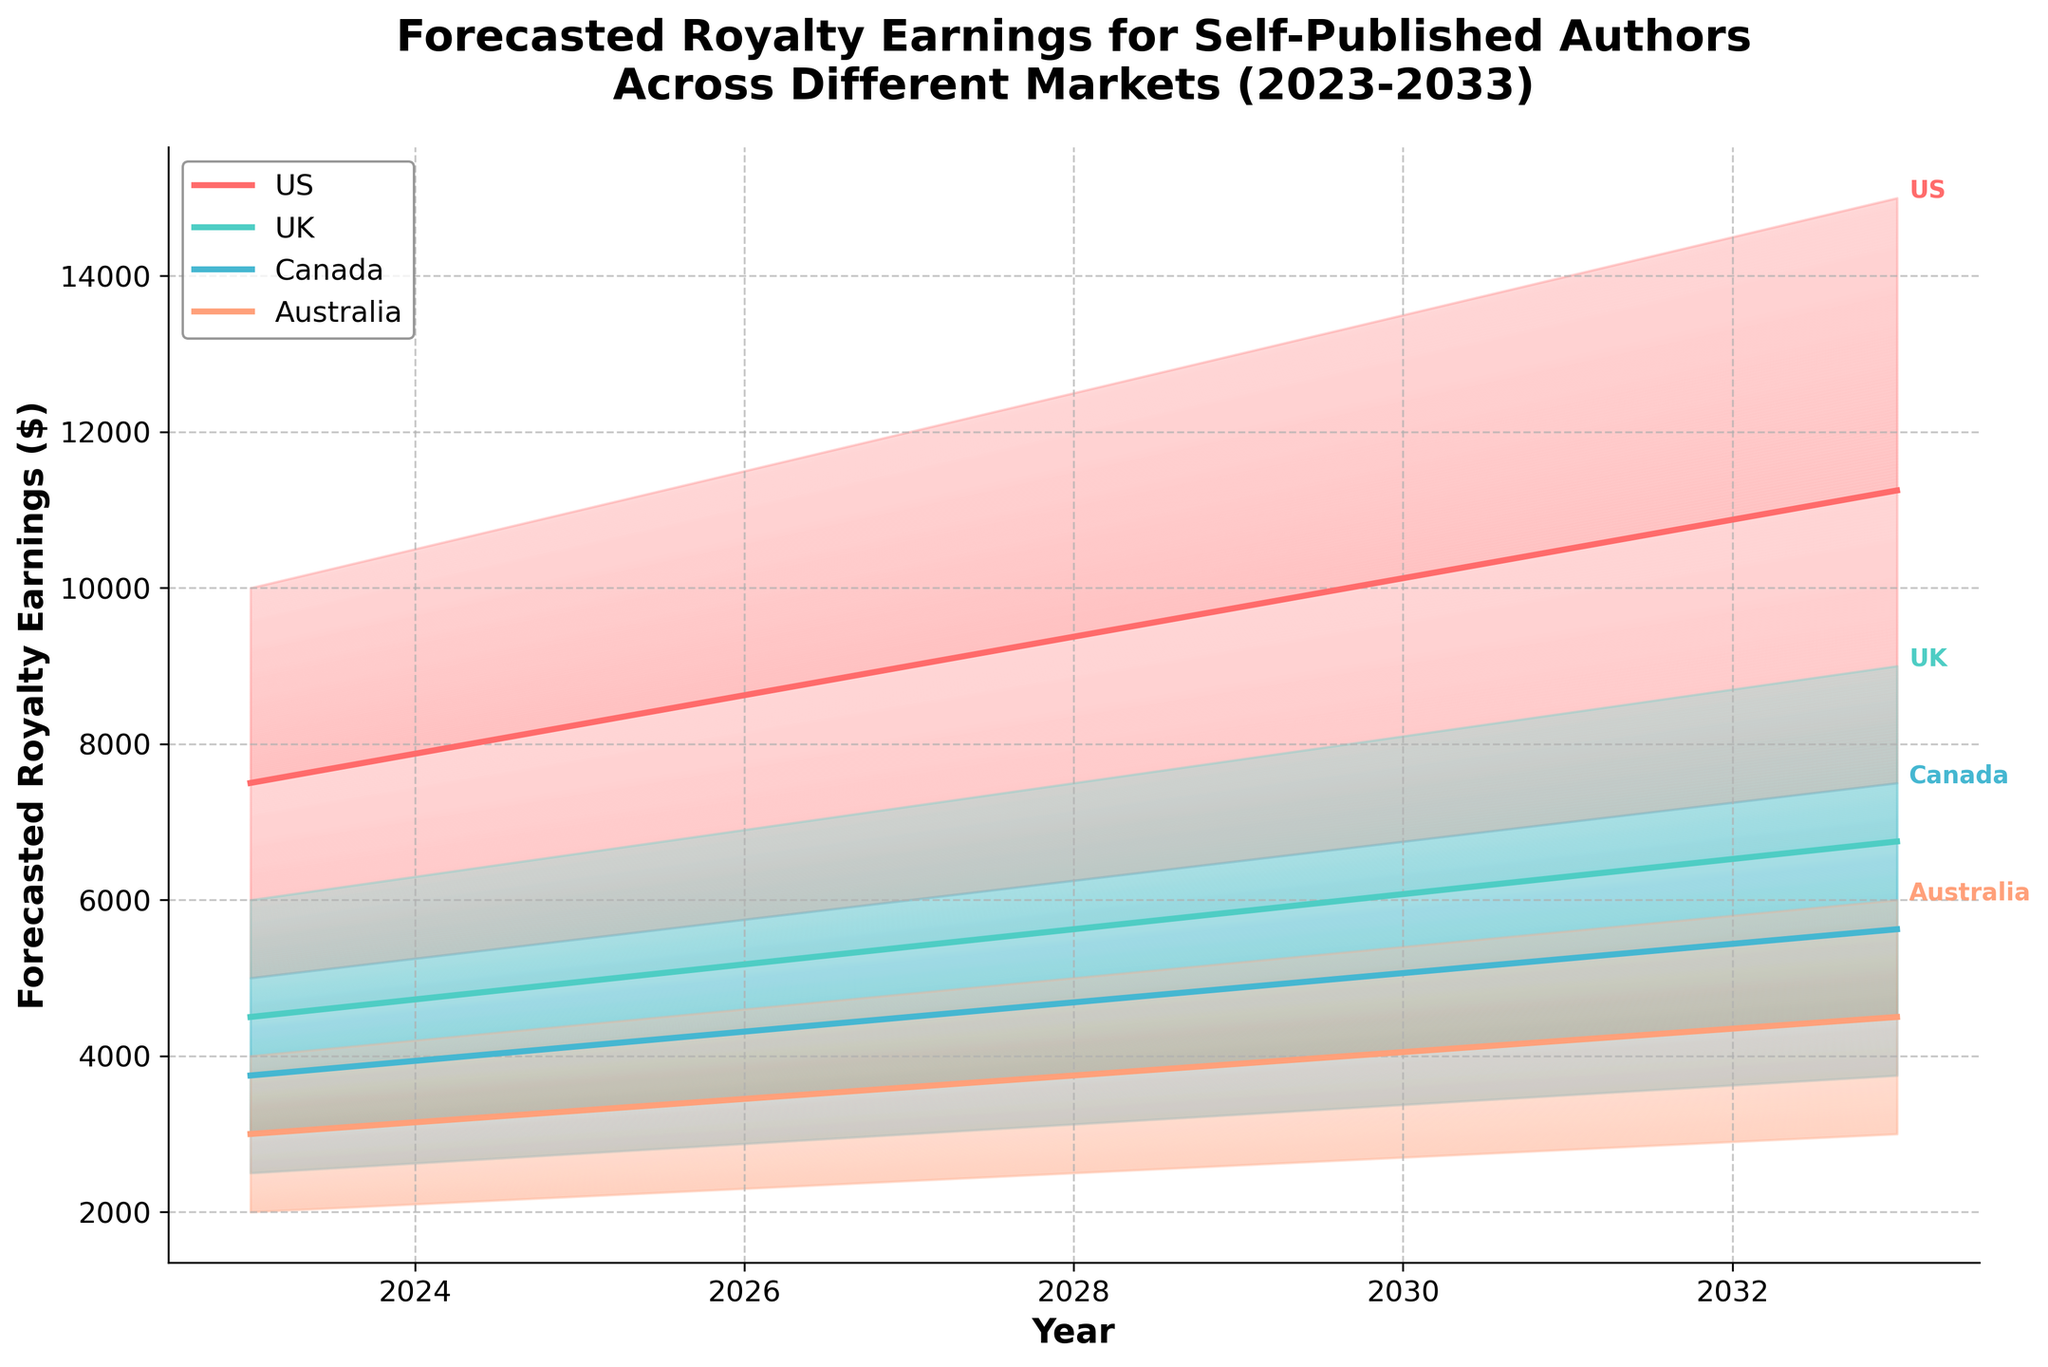What's the title of the figure? The title is prominently displayed at the top of the figure and summarizes what the figure is about.
Answer: Forecasted Royalty Earnings for Self-Published Authors Across Different Markets (2023-2033) What is the lowest forecasted earnings in Australia for the year 2025? The lowest earnings forecast for each year and market is represented by the bottom boundary of the shaded region. Locate the value on the y-axis corresponding to 2025 within the shaded region for Australia.
Answer: 2200 Which market shows the highest forecasted earnings median value in 2033? The median value for each market is represented by the central line within the shaded region for each market. Compare these midlines for the year 2033.
Answer: US How does the forecasted median value for the US market change from 2023 to 2033? Track the central line of the shaded region for the US market from the year 2023 to 2033 and find the difference in values.
Answer: It increases by 3750 Compare the forecasted highest earnings between the UK and Canada for 2029. Which is greater? Locate the top boundary of the shaded regions for both the UK and Canada markets in the year 2029 and compare the values.
Answer: The UK is greater (7800 vs. 6500) What is the general trend of the forecasted earnings for all markets from 2023 to 2033? The trend can be identified by looking at the general direction in which the shaded regions and central lines move over the years for all markets.
Answer: Upward trend Which year shows the smallest range between the forecasted lowest and highest earnings for the US market? For each year, subtract the lowest forecasted value from the highest for the US market and find the year with the smallest range.
Answer: 2023 (10000 - 5000 = 5000) In which year do all markets show a central forecast line above 5000? Examine the midlines of all market shaded regions for each year and identify the earliest year where all midlines are above 5000.
Answer: 2029 How does the forecasted earnings range in the UK market change from 2027 to 2031? Calculate the difference between the highest and lowest forecasted values for the UK market in 2027 and 2031 and compare these ranges.
Answer: It increases by 600 What are the colors used to represent the different markets in the figure? Each market is represented by a distinct color in the figure. Identify these colors as seen in the legend or the shaded regions of the fan chart.
Answer: US: Red, UK: Cyan, Canada: Blue, Australia: Salmon 